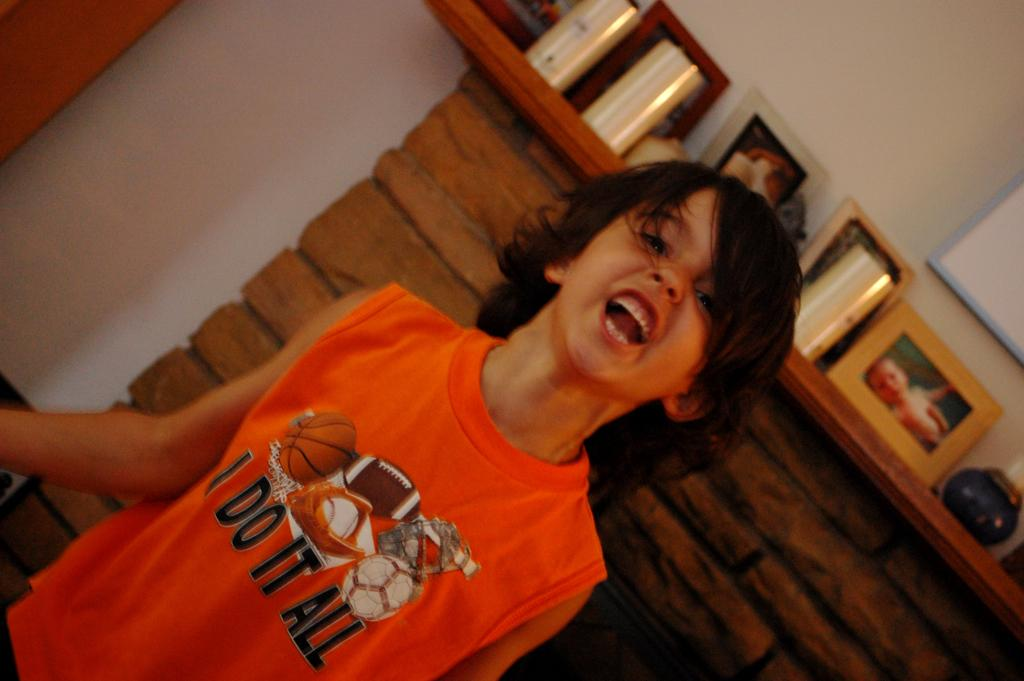<image>
Render a clear and concise summary of the photo. A young child wearing an orange vest reading I do it all. 